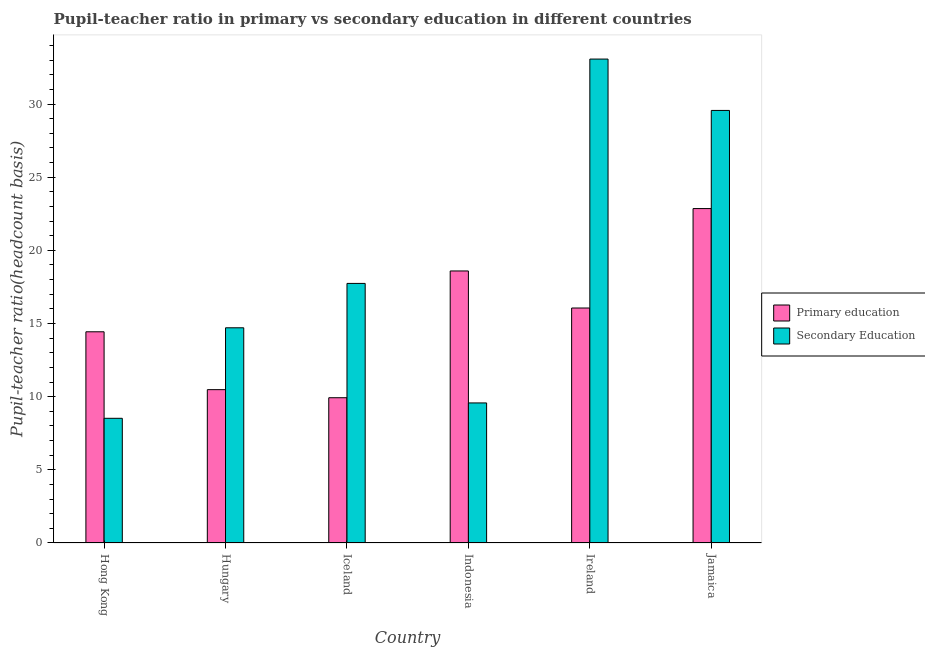How many different coloured bars are there?
Provide a succinct answer. 2. How many groups of bars are there?
Offer a terse response. 6. How many bars are there on the 5th tick from the left?
Your answer should be very brief. 2. What is the label of the 4th group of bars from the left?
Make the answer very short. Indonesia. In how many cases, is the number of bars for a given country not equal to the number of legend labels?
Keep it short and to the point. 0. What is the pupil-teacher ratio in primary education in Iceland?
Offer a terse response. 9.93. Across all countries, what is the maximum pupil-teacher ratio in primary education?
Give a very brief answer. 22.86. Across all countries, what is the minimum pupil-teacher ratio in primary education?
Your answer should be very brief. 9.93. In which country was the pupil teacher ratio on secondary education maximum?
Provide a short and direct response. Ireland. In which country was the pupil teacher ratio on secondary education minimum?
Give a very brief answer. Hong Kong. What is the total pupil teacher ratio on secondary education in the graph?
Keep it short and to the point. 113.18. What is the difference between the pupil-teacher ratio in primary education in Hong Kong and that in Indonesia?
Provide a succinct answer. -4.16. What is the difference between the pupil teacher ratio on secondary education in Indonesia and the pupil-teacher ratio in primary education in Hungary?
Offer a very short reply. -0.91. What is the average pupil-teacher ratio in primary education per country?
Provide a succinct answer. 15.39. What is the difference between the pupil teacher ratio on secondary education and pupil-teacher ratio in primary education in Ireland?
Your answer should be compact. 17.01. In how many countries, is the pupil-teacher ratio in primary education greater than 13 ?
Give a very brief answer. 4. What is the ratio of the pupil-teacher ratio in primary education in Hungary to that in Jamaica?
Provide a succinct answer. 0.46. What is the difference between the highest and the second highest pupil teacher ratio on secondary education?
Offer a very short reply. 3.51. What is the difference between the highest and the lowest pupil-teacher ratio in primary education?
Provide a short and direct response. 12.93. Is the sum of the pupil teacher ratio on secondary education in Hungary and Indonesia greater than the maximum pupil-teacher ratio in primary education across all countries?
Your answer should be compact. Yes. What does the 1st bar from the left in Hong Kong represents?
Ensure brevity in your answer.  Primary education. How many bars are there?
Make the answer very short. 12. What is the difference between two consecutive major ticks on the Y-axis?
Offer a very short reply. 5. Are the values on the major ticks of Y-axis written in scientific E-notation?
Your answer should be very brief. No. What is the title of the graph?
Your response must be concise. Pupil-teacher ratio in primary vs secondary education in different countries. Does "Resident" appear as one of the legend labels in the graph?
Your answer should be very brief. No. What is the label or title of the X-axis?
Your answer should be very brief. Country. What is the label or title of the Y-axis?
Offer a very short reply. Pupil-teacher ratio(headcount basis). What is the Pupil-teacher ratio(headcount basis) in Primary education in Hong Kong?
Provide a short and direct response. 14.43. What is the Pupil-teacher ratio(headcount basis) in Secondary Education in Hong Kong?
Your answer should be very brief. 8.52. What is the Pupil-teacher ratio(headcount basis) in Primary education in Hungary?
Keep it short and to the point. 10.48. What is the Pupil-teacher ratio(headcount basis) in Secondary Education in Hungary?
Give a very brief answer. 14.71. What is the Pupil-teacher ratio(headcount basis) of Primary education in Iceland?
Offer a very short reply. 9.93. What is the Pupil-teacher ratio(headcount basis) of Secondary Education in Iceland?
Make the answer very short. 17.74. What is the Pupil-teacher ratio(headcount basis) in Primary education in Indonesia?
Offer a very short reply. 18.59. What is the Pupil-teacher ratio(headcount basis) of Secondary Education in Indonesia?
Your answer should be compact. 9.57. What is the Pupil-teacher ratio(headcount basis) in Primary education in Ireland?
Offer a very short reply. 16.06. What is the Pupil-teacher ratio(headcount basis) in Secondary Education in Ireland?
Make the answer very short. 33.07. What is the Pupil-teacher ratio(headcount basis) of Primary education in Jamaica?
Ensure brevity in your answer.  22.86. What is the Pupil-teacher ratio(headcount basis) of Secondary Education in Jamaica?
Give a very brief answer. 29.56. Across all countries, what is the maximum Pupil-teacher ratio(headcount basis) in Primary education?
Your response must be concise. 22.86. Across all countries, what is the maximum Pupil-teacher ratio(headcount basis) in Secondary Education?
Offer a terse response. 33.07. Across all countries, what is the minimum Pupil-teacher ratio(headcount basis) in Primary education?
Ensure brevity in your answer.  9.93. Across all countries, what is the minimum Pupil-teacher ratio(headcount basis) of Secondary Education?
Your response must be concise. 8.52. What is the total Pupil-teacher ratio(headcount basis) of Primary education in the graph?
Your answer should be compact. 92.35. What is the total Pupil-teacher ratio(headcount basis) in Secondary Education in the graph?
Make the answer very short. 113.18. What is the difference between the Pupil-teacher ratio(headcount basis) in Primary education in Hong Kong and that in Hungary?
Your answer should be compact. 3.95. What is the difference between the Pupil-teacher ratio(headcount basis) in Secondary Education in Hong Kong and that in Hungary?
Your answer should be compact. -6.19. What is the difference between the Pupil-teacher ratio(headcount basis) in Primary education in Hong Kong and that in Iceland?
Ensure brevity in your answer.  4.51. What is the difference between the Pupil-teacher ratio(headcount basis) of Secondary Education in Hong Kong and that in Iceland?
Ensure brevity in your answer.  -9.22. What is the difference between the Pupil-teacher ratio(headcount basis) in Primary education in Hong Kong and that in Indonesia?
Give a very brief answer. -4.16. What is the difference between the Pupil-teacher ratio(headcount basis) in Secondary Education in Hong Kong and that in Indonesia?
Make the answer very short. -1.05. What is the difference between the Pupil-teacher ratio(headcount basis) in Primary education in Hong Kong and that in Ireland?
Make the answer very short. -1.63. What is the difference between the Pupil-teacher ratio(headcount basis) in Secondary Education in Hong Kong and that in Ireland?
Ensure brevity in your answer.  -24.55. What is the difference between the Pupil-teacher ratio(headcount basis) in Primary education in Hong Kong and that in Jamaica?
Provide a short and direct response. -8.42. What is the difference between the Pupil-teacher ratio(headcount basis) in Secondary Education in Hong Kong and that in Jamaica?
Offer a terse response. -21.04. What is the difference between the Pupil-teacher ratio(headcount basis) of Primary education in Hungary and that in Iceland?
Keep it short and to the point. 0.55. What is the difference between the Pupil-teacher ratio(headcount basis) of Secondary Education in Hungary and that in Iceland?
Provide a succinct answer. -3.03. What is the difference between the Pupil-teacher ratio(headcount basis) of Primary education in Hungary and that in Indonesia?
Provide a short and direct response. -8.11. What is the difference between the Pupil-teacher ratio(headcount basis) in Secondary Education in Hungary and that in Indonesia?
Keep it short and to the point. 5.14. What is the difference between the Pupil-teacher ratio(headcount basis) of Primary education in Hungary and that in Ireland?
Provide a short and direct response. -5.58. What is the difference between the Pupil-teacher ratio(headcount basis) in Secondary Education in Hungary and that in Ireland?
Provide a short and direct response. -18.37. What is the difference between the Pupil-teacher ratio(headcount basis) of Primary education in Hungary and that in Jamaica?
Provide a succinct answer. -12.38. What is the difference between the Pupil-teacher ratio(headcount basis) in Secondary Education in Hungary and that in Jamaica?
Give a very brief answer. -14.86. What is the difference between the Pupil-teacher ratio(headcount basis) in Primary education in Iceland and that in Indonesia?
Your answer should be very brief. -8.66. What is the difference between the Pupil-teacher ratio(headcount basis) of Secondary Education in Iceland and that in Indonesia?
Your response must be concise. 8.17. What is the difference between the Pupil-teacher ratio(headcount basis) in Primary education in Iceland and that in Ireland?
Your answer should be very brief. -6.13. What is the difference between the Pupil-teacher ratio(headcount basis) in Secondary Education in Iceland and that in Ireland?
Provide a short and direct response. -15.33. What is the difference between the Pupil-teacher ratio(headcount basis) of Primary education in Iceland and that in Jamaica?
Offer a very short reply. -12.93. What is the difference between the Pupil-teacher ratio(headcount basis) of Secondary Education in Iceland and that in Jamaica?
Offer a very short reply. -11.82. What is the difference between the Pupil-teacher ratio(headcount basis) in Primary education in Indonesia and that in Ireland?
Give a very brief answer. 2.53. What is the difference between the Pupil-teacher ratio(headcount basis) of Secondary Education in Indonesia and that in Ireland?
Give a very brief answer. -23.5. What is the difference between the Pupil-teacher ratio(headcount basis) of Primary education in Indonesia and that in Jamaica?
Offer a terse response. -4.26. What is the difference between the Pupil-teacher ratio(headcount basis) in Secondary Education in Indonesia and that in Jamaica?
Make the answer very short. -19.99. What is the difference between the Pupil-teacher ratio(headcount basis) of Primary education in Ireland and that in Jamaica?
Your answer should be very brief. -6.8. What is the difference between the Pupil-teacher ratio(headcount basis) of Secondary Education in Ireland and that in Jamaica?
Provide a succinct answer. 3.51. What is the difference between the Pupil-teacher ratio(headcount basis) of Primary education in Hong Kong and the Pupil-teacher ratio(headcount basis) of Secondary Education in Hungary?
Offer a terse response. -0.27. What is the difference between the Pupil-teacher ratio(headcount basis) of Primary education in Hong Kong and the Pupil-teacher ratio(headcount basis) of Secondary Education in Iceland?
Your response must be concise. -3.31. What is the difference between the Pupil-teacher ratio(headcount basis) of Primary education in Hong Kong and the Pupil-teacher ratio(headcount basis) of Secondary Education in Indonesia?
Your answer should be compact. 4.86. What is the difference between the Pupil-teacher ratio(headcount basis) in Primary education in Hong Kong and the Pupil-teacher ratio(headcount basis) in Secondary Education in Ireland?
Your response must be concise. -18.64. What is the difference between the Pupil-teacher ratio(headcount basis) of Primary education in Hong Kong and the Pupil-teacher ratio(headcount basis) of Secondary Education in Jamaica?
Offer a very short reply. -15.13. What is the difference between the Pupil-teacher ratio(headcount basis) in Primary education in Hungary and the Pupil-teacher ratio(headcount basis) in Secondary Education in Iceland?
Offer a terse response. -7.26. What is the difference between the Pupil-teacher ratio(headcount basis) in Primary education in Hungary and the Pupil-teacher ratio(headcount basis) in Secondary Education in Indonesia?
Provide a succinct answer. 0.91. What is the difference between the Pupil-teacher ratio(headcount basis) of Primary education in Hungary and the Pupil-teacher ratio(headcount basis) of Secondary Education in Ireland?
Your response must be concise. -22.59. What is the difference between the Pupil-teacher ratio(headcount basis) of Primary education in Hungary and the Pupil-teacher ratio(headcount basis) of Secondary Education in Jamaica?
Offer a very short reply. -19.08. What is the difference between the Pupil-teacher ratio(headcount basis) in Primary education in Iceland and the Pupil-teacher ratio(headcount basis) in Secondary Education in Indonesia?
Provide a short and direct response. 0.36. What is the difference between the Pupil-teacher ratio(headcount basis) of Primary education in Iceland and the Pupil-teacher ratio(headcount basis) of Secondary Education in Ireland?
Make the answer very short. -23.15. What is the difference between the Pupil-teacher ratio(headcount basis) of Primary education in Iceland and the Pupil-teacher ratio(headcount basis) of Secondary Education in Jamaica?
Give a very brief answer. -19.64. What is the difference between the Pupil-teacher ratio(headcount basis) of Primary education in Indonesia and the Pupil-teacher ratio(headcount basis) of Secondary Education in Ireland?
Offer a terse response. -14.48. What is the difference between the Pupil-teacher ratio(headcount basis) of Primary education in Indonesia and the Pupil-teacher ratio(headcount basis) of Secondary Education in Jamaica?
Provide a succinct answer. -10.97. What is the difference between the Pupil-teacher ratio(headcount basis) of Primary education in Ireland and the Pupil-teacher ratio(headcount basis) of Secondary Education in Jamaica?
Provide a succinct answer. -13.5. What is the average Pupil-teacher ratio(headcount basis) in Primary education per country?
Give a very brief answer. 15.39. What is the average Pupil-teacher ratio(headcount basis) of Secondary Education per country?
Provide a succinct answer. 18.86. What is the difference between the Pupil-teacher ratio(headcount basis) in Primary education and Pupil-teacher ratio(headcount basis) in Secondary Education in Hong Kong?
Ensure brevity in your answer.  5.91. What is the difference between the Pupil-teacher ratio(headcount basis) of Primary education and Pupil-teacher ratio(headcount basis) of Secondary Education in Hungary?
Your answer should be compact. -4.23. What is the difference between the Pupil-teacher ratio(headcount basis) in Primary education and Pupil-teacher ratio(headcount basis) in Secondary Education in Iceland?
Keep it short and to the point. -7.81. What is the difference between the Pupil-teacher ratio(headcount basis) in Primary education and Pupil-teacher ratio(headcount basis) in Secondary Education in Indonesia?
Offer a very short reply. 9.02. What is the difference between the Pupil-teacher ratio(headcount basis) in Primary education and Pupil-teacher ratio(headcount basis) in Secondary Education in Ireland?
Give a very brief answer. -17.01. What is the difference between the Pupil-teacher ratio(headcount basis) in Primary education and Pupil-teacher ratio(headcount basis) in Secondary Education in Jamaica?
Give a very brief answer. -6.71. What is the ratio of the Pupil-teacher ratio(headcount basis) in Primary education in Hong Kong to that in Hungary?
Give a very brief answer. 1.38. What is the ratio of the Pupil-teacher ratio(headcount basis) in Secondary Education in Hong Kong to that in Hungary?
Your answer should be compact. 0.58. What is the ratio of the Pupil-teacher ratio(headcount basis) in Primary education in Hong Kong to that in Iceland?
Make the answer very short. 1.45. What is the ratio of the Pupil-teacher ratio(headcount basis) in Secondary Education in Hong Kong to that in Iceland?
Offer a terse response. 0.48. What is the ratio of the Pupil-teacher ratio(headcount basis) in Primary education in Hong Kong to that in Indonesia?
Keep it short and to the point. 0.78. What is the ratio of the Pupil-teacher ratio(headcount basis) in Secondary Education in Hong Kong to that in Indonesia?
Your response must be concise. 0.89. What is the ratio of the Pupil-teacher ratio(headcount basis) of Primary education in Hong Kong to that in Ireland?
Make the answer very short. 0.9. What is the ratio of the Pupil-teacher ratio(headcount basis) in Secondary Education in Hong Kong to that in Ireland?
Offer a very short reply. 0.26. What is the ratio of the Pupil-teacher ratio(headcount basis) in Primary education in Hong Kong to that in Jamaica?
Offer a very short reply. 0.63. What is the ratio of the Pupil-teacher ratio(headcount basis) of Secondary Education in Hong Kong to that in Jamaica?
Offer a terse response. 0.29. What is the ratio of the Pupil-teacher ratio(headcount basis) of Primary education in Hungary to that in Iceland?
Provide a short and direct response. 1.06. What is the ratio of the Pupil-teacher ratio(headcount basis) in Secondary Education in Hungary to that in Iceland?
Provide a short and direct response. 0.83. What is the ratio of the Pupil-teacher ratio(headcount basis) of Primary education in Hungary to that in Indonesia?
Keep it short and to the point. 0.56. What is the ratio of the Pupil-teacher ratio(headcount basis) of Secondary Education in Hungary to that in Indonesia?
Provide a short and direct response. 1.54. What is the ratio of the Pupil-teacher ratio(headcount basis) of Primary education in Hungary to that in Ireland?
Give a very brief answer. 0.65. What is the ratio of the Pupil-teacher ratio(headcount basis) in Secondary Education in Hungary to that in Ireland?
Provide a succinct answer. 0.44. What is the ratio of the Pupil-teacher ratio(headcount basis) of Primary education in Hungary to that in Jamaica?
Offer a very short reply. 0.46. What is the ratio of the Pupil-teacher ratio(headcount basis) of Secondary Education in Hungary to that in Jamaica?
Provide a short and direct response. 0.5. What is the ratio of the Pupil-teacher ratio(headcount basis) of Primary education in Iceland to that in Indonesia?
Give a very brief answer. 0.53. What is the ratio of the Pupil-teacher ratio(headcount basis) in Secondary Education in Iceland to that in Indonesia?
Offer a very short reply. 1.85. What is the ratio of the Pupil-teacher ratio(headcount basis) in Primary education in Iceland to that in Ireland?
Give a very brief answer. 0.62. What is the ratio of the Pupil-teacher ratio(headcount basis) in Secondary Education in Iceland to that in Ireland?
Give a very brief answer. 0.54. What is the ratio of the Pupil-teacher ratio(headcount basis) of Primary education in Iceland to that in Jamaica?
Make the answer very short. 0.43. What is the ratio of the Pupil-teacher ratio(headcount basis) in Secondary Education in Iceland to that in Jamaica?
Your response must be concise. 0.6. What is the ratio of the Pupil-teacher ratio(headcount basis) of Primary education in Indonesia to that in Ireland?
Ensure brevity in your answer.  1.16. What is the ratio of the Pupil-teacher ratio(headcount basis) in Secondary Education in Indonesia to that in Ireland?
Make the answer very short. 0.29. What is the ratio of the Pupil-teacher ratio(headcount basis) in Primary education in Indonesia to that in Jamaica?
Your answer should be compact. 0.81. What is the ratio of the Pupil-teacher ratio(headcount basis) in Secondary Education in Indonesia to that in Jamaica?
Your answer should be compact. 0.32. What is the ratio of the Pupil-teacher ratio(headcount basis) of Primary education in Ireland to that in Jamaica?
Give a very brief answer. 0.7. What is the ratio of the Pupil-teacher ratio(headcount basis) of Secondary Education in Ireland to that in Jamaica?
Offer a very short reply. 1.12. What is the difference between the highest and the second highest Pupil-teacher ratio(headcount basis) in Primary education?
Give a very brief answer. 4.26. What is the difference between the highest and the second highest Pupil-teacher ratio(headcount basis) in Secondary Education?
Your answer should be very brief. 3.51. What is the difference between the highest and the lowest Pupil-teacher ratio(headcount basis) in Primary education?
Your answer should be very brief. 12.93. What is the difference between the highest and the lowest Pupil-teacher ratio(headcount basis) in Secondary Education?
Provide a succinct answer. 24.55. 